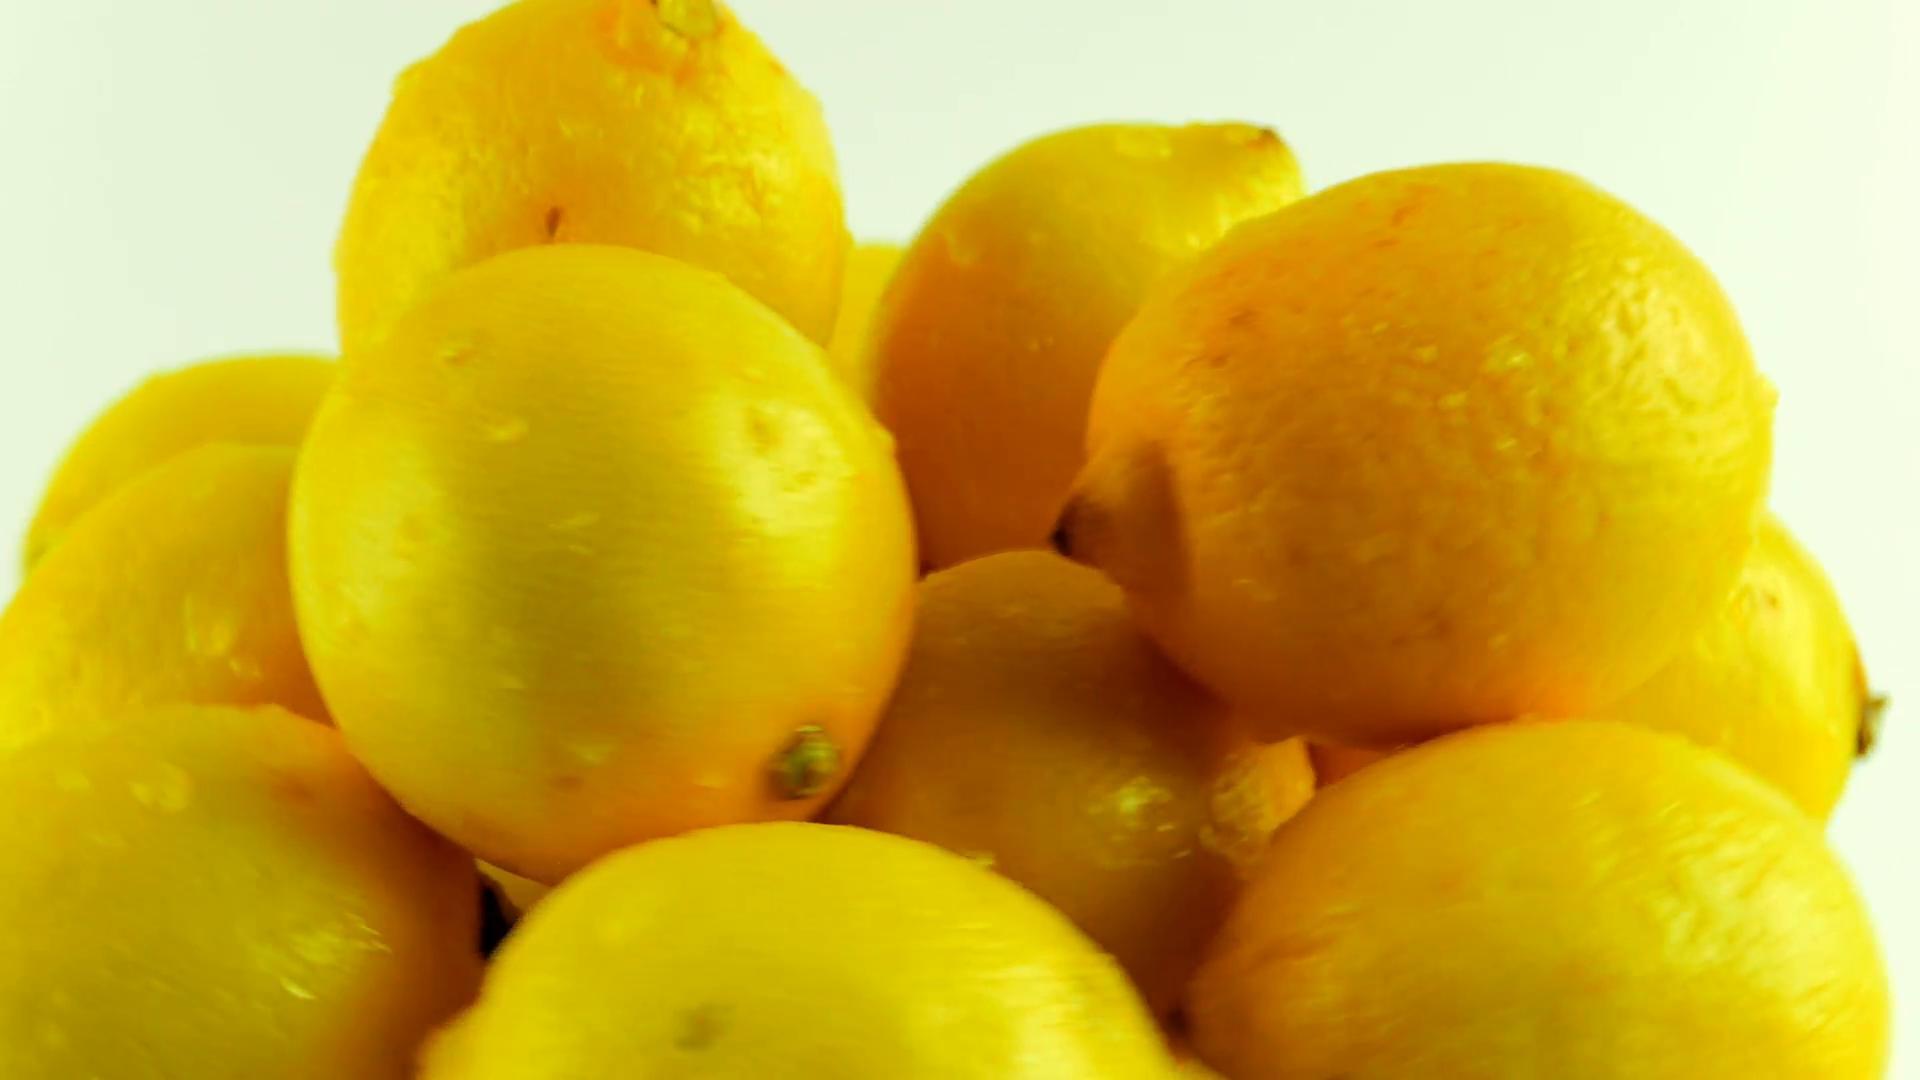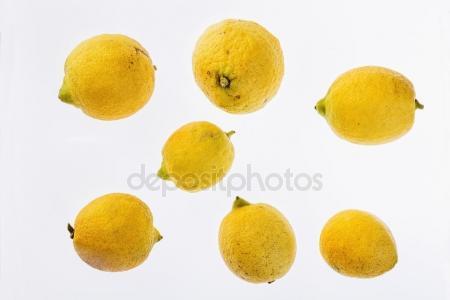The first image is the image on the left, the second image is the image on the right. Evaluate the accuracy of this statement regarding the images: "The combined images include exactly one cut half lemon and at least eleven whole citrus fruits.". Is it true? Answer yes or no. No. The first image is the image on the left, the second image is the image on the right. Evaluate the accuracy of this statement regarding the images: "There is a sliced lemon in exactly one image.". Is it true? Answer yes or no. No. 